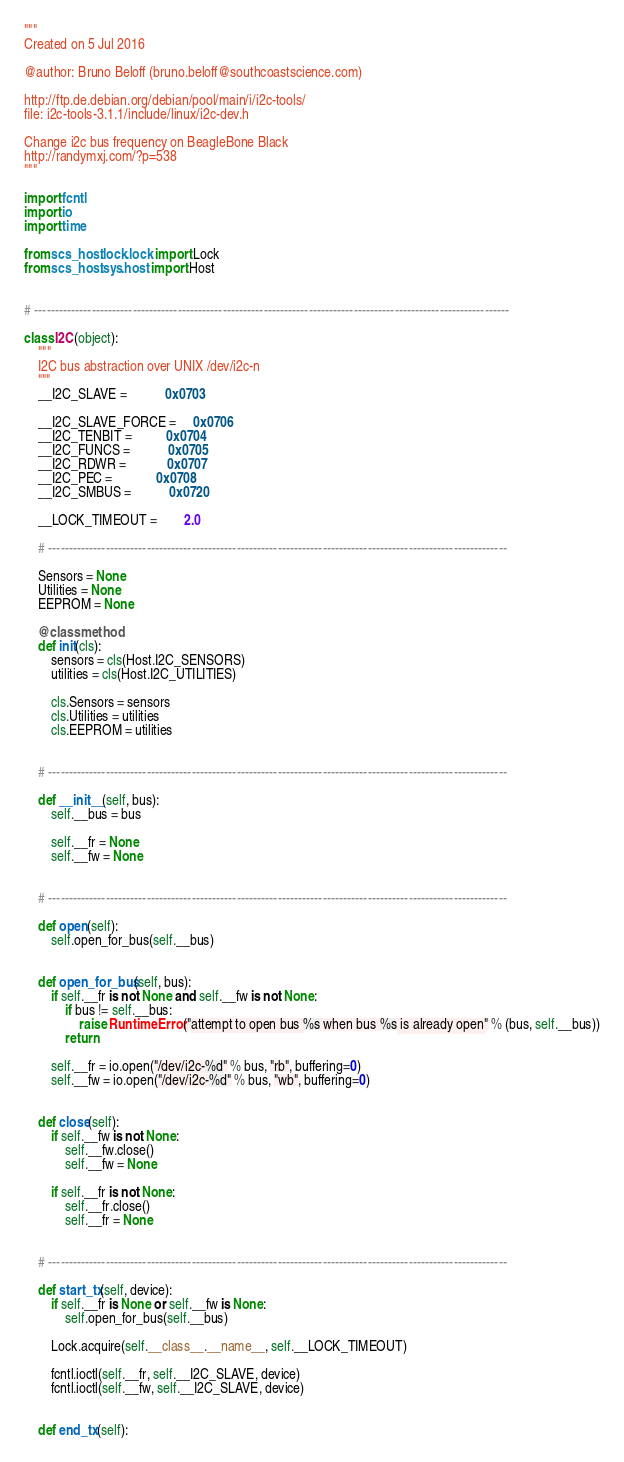<code> <loc_0><loc_0><loc_500><loc_500><_Python_>"""
Created on 5 Jul 2016

@author: Bruno Beloff (bruno.beloff@southcoastscience.com)

http://ftp.de.debian.org/debian/pool/main/i/i2c-tools/
file: i2c-tools-3.1.1/include/linux/i2c-dev.h

Change i2c bus frequency on BeagleBone Black
http://randymxj.com/?p=538
"""

import fcntl
import io
import time

from scs_host.lock.lock import Lock
from scs_host.sys.host import Host


# --------------------------------------------------------------------------------------------------------------------

class I2C(object):
    """
    I2C bus abstraction over UNIX /dev/i2c-n
    """
    __I2C_SLAVE =           0x0703

    __I2C_SLAVE_FORCE =     0x0706
    __I2C_TENBIT =          0x0704
    __I2C_FUNCS =           0x0705
    __I2C_RDWR =            0x0707
    __I2C_PEC =             0x0708
    __I2C_SMBUS =           0x0720

    __LOCK_TIMEOUT =        2.0

    # ----------------------------------------------------------------------------------------------------------------

    Sensors = None
    Utilities = None
    EEPROM = None

    @classmethod
    def init(cls):
        sensors = cls(Host.I2C_SENSORS)
        utilities = cls(Host.I2C_UTILITIES)

        cls.Sensors = sensors
        cls.Utilities = utilities
        cls.EEPROM = utilities


    # ----------------------------------------------------------------------------------------------------------------

    def __init__(self, bus):
        self.__bus = bus

        self.__fr = None
        self.__fw = None


    # ----------------------------------------------------------------------------------------------------------------

    def open(self):
        self.open_for_bus(self.__bus)


    def open_for_bus(self, bus):
        if self.__fr is not None and self.__fw is not None:
            if bus != self.__bus:
                raise RuntimeError("attempt to open bus %s when bus %s is already open" % (bus, self.__bus))
            return

        self.__fr = io.open("/dev/i2c-%d" % bus, "rb", buffering=0)
        self.__fw = io.open("/dev/i2c-%d" % bus, "wb", buffering=0)


    def close(self):
        if self.__fw is not None:
            self.__fw.close()
            self.__fw = None

        if self.__fr is not None:
            self.__fr.close()
            self.__fr = None


    # ----------------------------------------------------------------------------------------------------------------

    def start_tx(self, device):
        if self.__fr is None or self.__fw is None:
            self.open_for_bus(self.__bus)

        Lock.acquire(self.__class__.__name__, self.__LOCK_TIMEOUT)

        fcntl.ioctl(self.__fr, self.__I2C_SLAVE, device)
        fcntl.ioctl(self.__fw, self.__I2C_SLAVE, device)


    def end_tx(self):</code> 